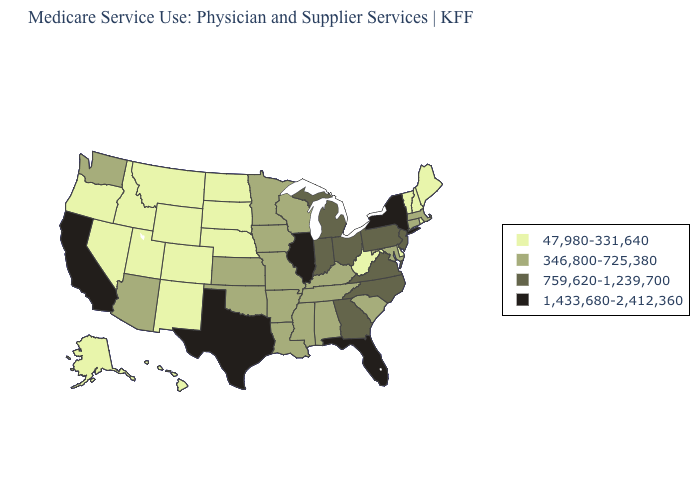Does New Jersey have a lower value than Minnesota?
Give a very brief answer. No. Does the map have missing data?
Give a very brief answer. No. What is the value of New Jersey?
Quick response, please. 759,620-1,239,700. Name the states that have a value in the range 759,620-1,239,700?
Write a very short answer. Georgia, Indiana, Michigan, New Jersey, North Carolina, Ohio, Pennsylvania, Virginia. Does New Hampshire have a lower value than Rhode Island?
Quick response, please. No. Is the legend a continuous bar?
Be succinct. No. Name the states that have a value in the range 1,433,680-2,412,360?
Concise answer only. California, Florida, Illinois, New York, Texas. Does Nevada have the lowest value in the USA?
Answer briefly. Yes. Name the states that have a value in the range 47,980-331,640?
Write a very short answer. Alaska, Colorado, Delaware, Hawaii, Idaho, Maine, Montana, Nebraska, Nevada, New Hampshire, New Mexico, North Dakota, Oregon, Rhode Island, South Dakota, Utah, Vermont, West Virginia, Wyoming. Name the states that have a value in the range 346,800-725,380?
Keep it brief. Alabama, Arizona, Arkansas, Connecticut, Iowa, Kansas, Kentucky, Louisiana, Maryland, Massachusetts, Minnesota, Mississippi, Missouri, Oklahoma, South Carolina, Tennessee, Washington, Wisconsin. What is the value of Arkansas?
Be succinct. 346,800-725,380. Among the states that border Missouri , does Illinois have the highest value?
Short answer required. Yes. Among the states that border Oregon , which have the lowest value?
Answer briefly. Idaho, Nevada. Does the map have missing data?
Answer briefly. No. What is the highest value in the MidWest ?
Answer briefly. 1,433,680-2,412,360. 